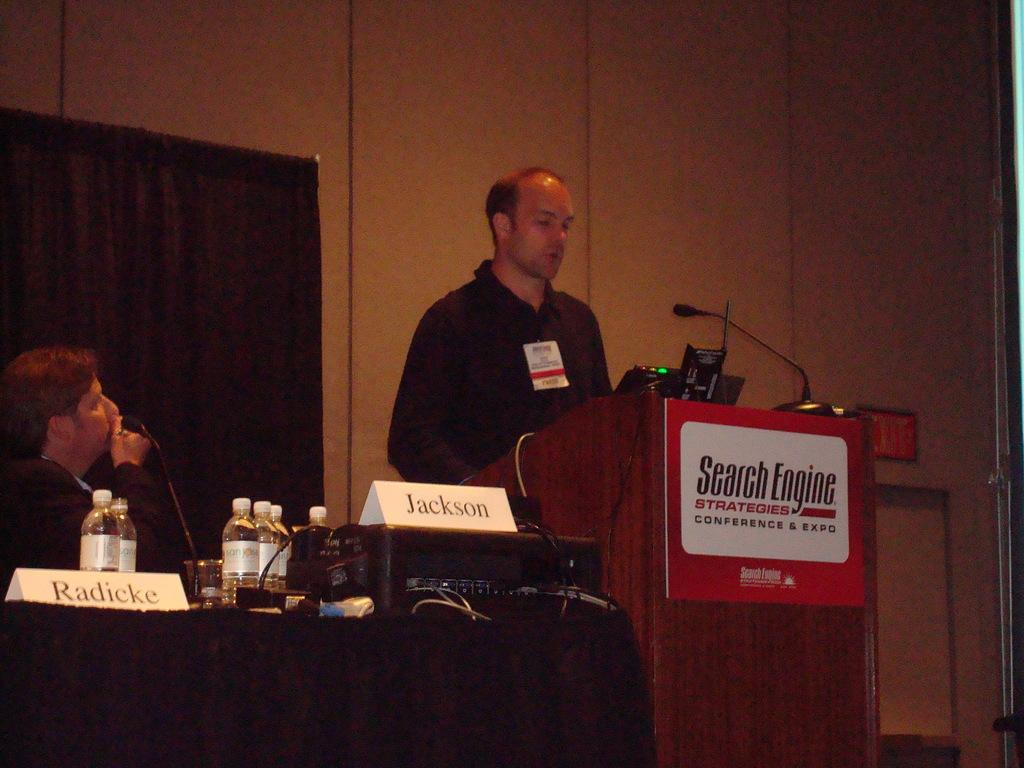What is the man on the right side of the image doing? There is a man standing near a podium on the right side of the image. What is the position of the man on the left side of the image? There is a man sitting on the left side of the image. What type of zephyr can be seen blowing through the image? There is no zephyr present in the image. How does the expansion of the room affect the position of the men in the image? The position of the men in the image is not affected by any expansion, as the facts do not mention any changes in the room's size. 